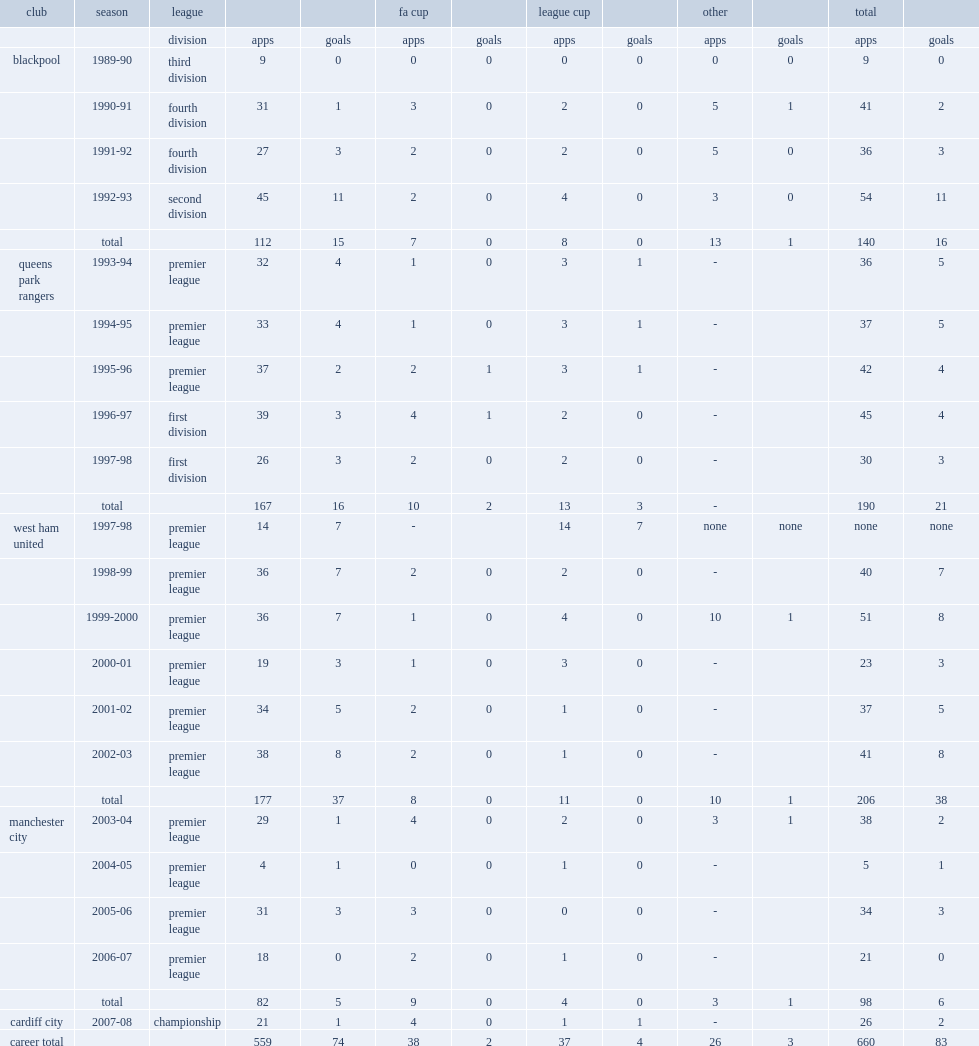How many league goals did trevor sinclair score for trevor sinclair totally. 15.0. 